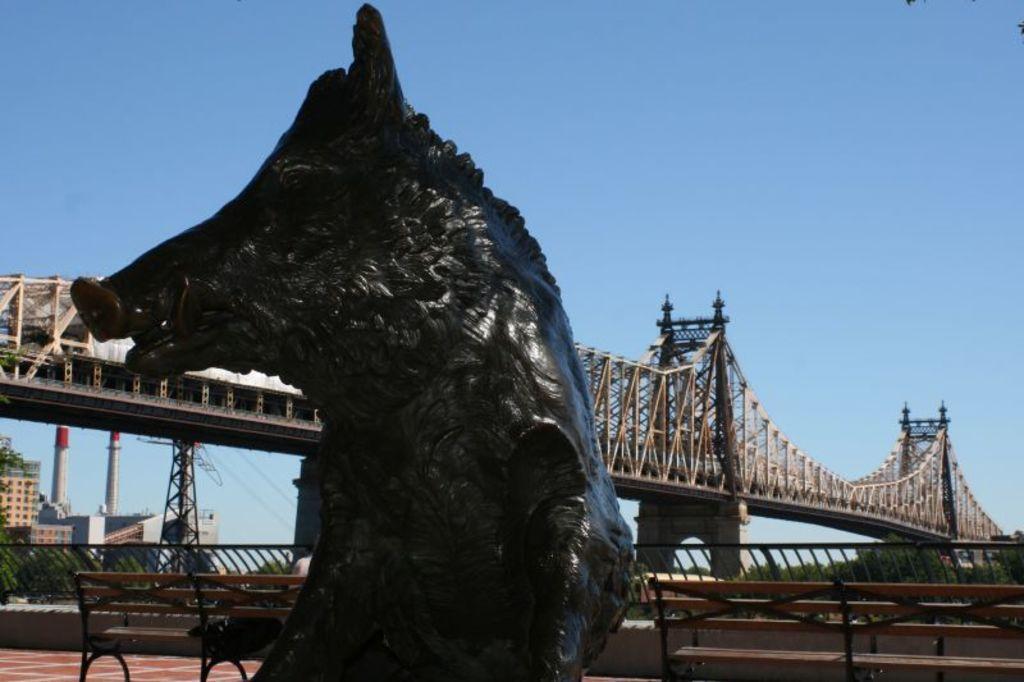In one or two sentences, can you explain what this image depicts? In this picture there is a animal statue towards the left. Towards the right there are two benches, towards the left there is one bench. In the background there are trees, buildings, a bridge and a sky. 